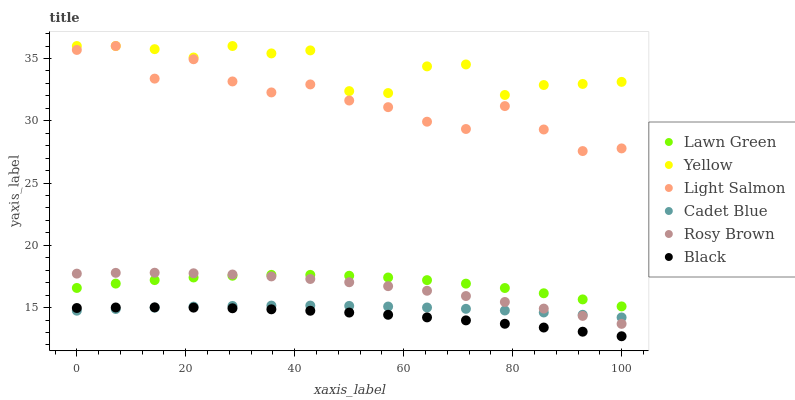Does Black have the minimum area under the curve?
Answer yes or no. Yes. Does Yellow have the maximum area under the curve?
Answer yes or no. Yes. Does Light Salmon have the minimum area under the curve?
Answer yes or no. No. Does Light Salmon have the maximum area under the curve?
Answer yes or no. No. Is Cadet Blue the smoothest?
Answer yes or no. Yes. Is Light Salmon the roughest?
Answer yes or no. Yes. Is Light Salmon the smoothest?
Answer yes or no. No. Is Cadet Blue the roughest?
Answer yes or no. No. Does Black have the lowest value?
Answer yes or no. Yes. Does Light Salmon have the lowest value?
Answer yes or no. No. Does Yellow have the highest value?
Answer yes or no. Yes. Does Cadet Blue have the highest value?
Answer yes or no. No. Is Cadet Blue less than Light Salmon?
Answer yes or no. Yes. Is Yellow greater than Cadet Blue?
Answer yes or no. Yes. Does Black intersect Cadet Blue?
Answer yes or no. Yes. Is Black less than Cadet Blue?
Answer yes or no. No. Is Black greater than Cadet Blue?
Answer yes or no. No. Does Cadet Blue intersect Light Salmon?
Answer yes or no. No. 